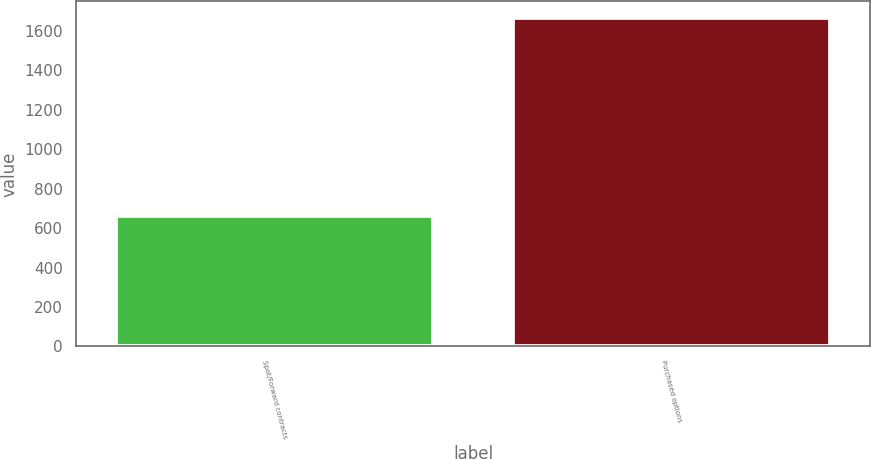Convert chart. <chart><loc_0><loc_0><loc_500><loc_500><bar_chart><fcel>Spot/Forward contracts<fcel>Purchased options<nl><fcel>662<fcel>1668<nl></chart> 